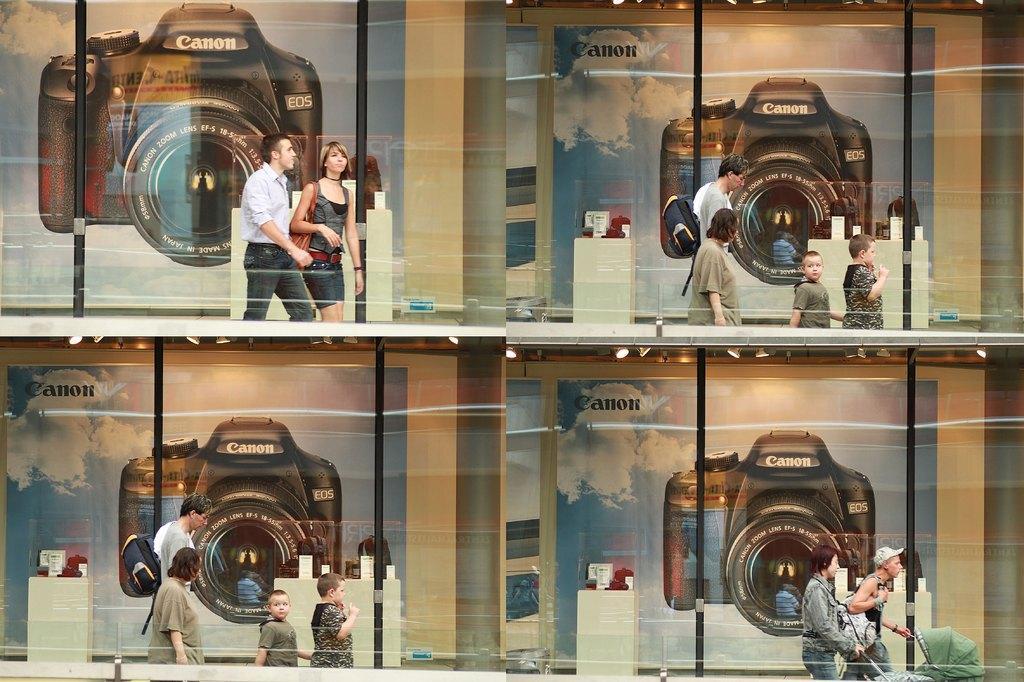In one or two sentences, can you explain what this image depicts? This is a collage image. In the background of the image there are posters of a camera and there are people. 